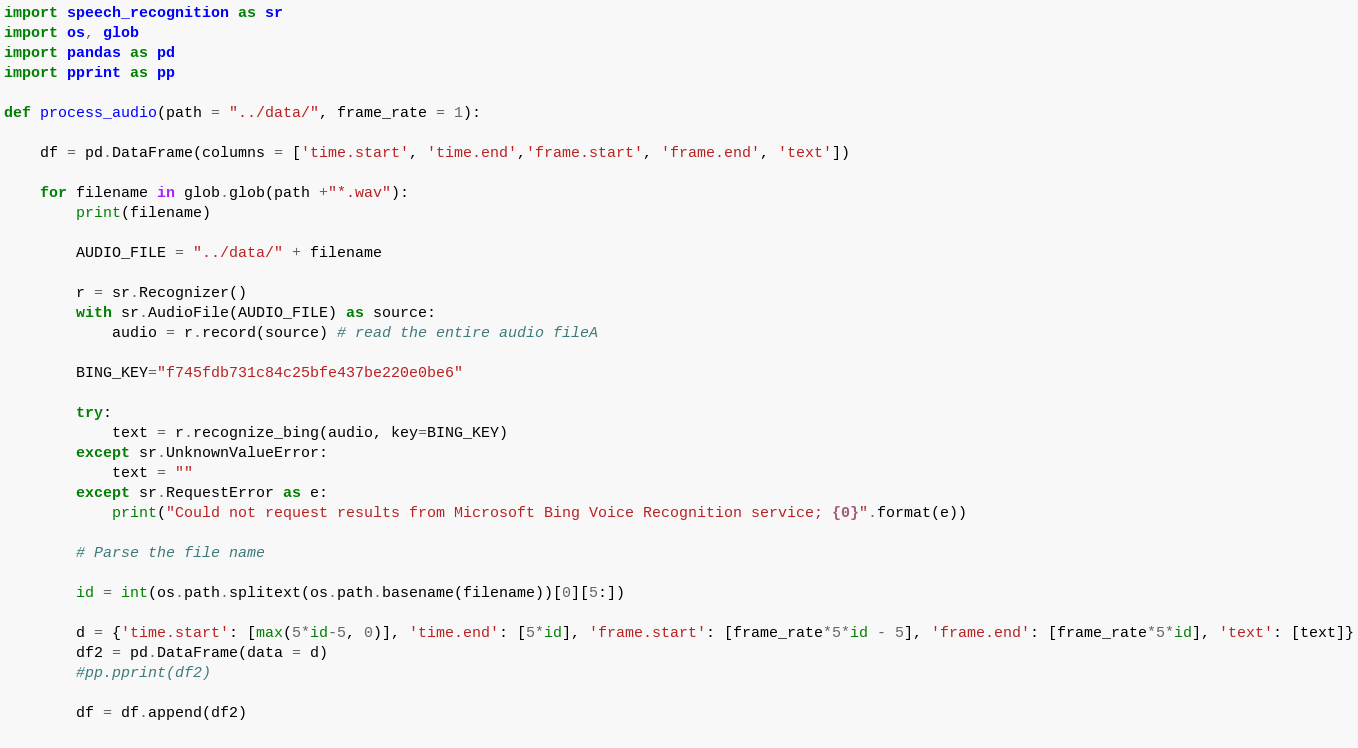Convert code to text. <code><loc_0><loc_0><loc_500><loc_500><_Python_>import speech_recognition as sr
import os, glob
import pandas as pd
import pprint as pp

def process_audio(path = "../data/", frame_rate = 1):

    df = pd.DataFrame(columns = ['time.start', 'time.end','frame.start', 'frame.end', 'text'])

    for filename in glob.glob(path +"*.wav"):
        print(filename)

        AUDIO_FILE = "../data/" + filename

        r = sr.Recognizer()
        with sr.AudioFile(AUDIO_FILE) as source:
            audio = r.record(source) # read the entire audio fileA

        BING_KEY="f745fdb731c84c25bfe437be220e0be6"

        try:
            text = r.recognize_bing(audio, key=BING_KEY)
        except sr.UnknownValueError:
            text = ""    
        except sr.RequestError as e:
            print("Could not request results from Microsoft Bing Voice Recognition service; {0}".format(e)) 

        # Parse the file name

        id = int(os.path.splitext(os.path.basename(filename))[0][5:])

        d = {'time.start': [max(5*id-5, 0)], 'time.end': [5*id], 'frame.start': [frame_rate*5*id - 5], 'frame.end': [frame_rate*5*id], 'text': [text]}
        df2 = pd.DataFrame(data = d) 
        #pp.pprint(df2)

        df = df.append(df2) 
      
</code> 